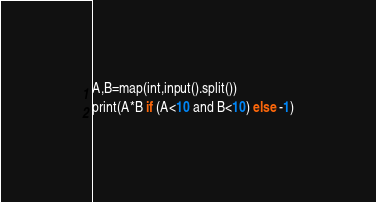Convert code to text. <code><loc_0><loc_0><loc_500><loc_500><_Python_>A,B=map(int,input().split())
print(A*B if (A<10 and B<10) else -1)</code> 